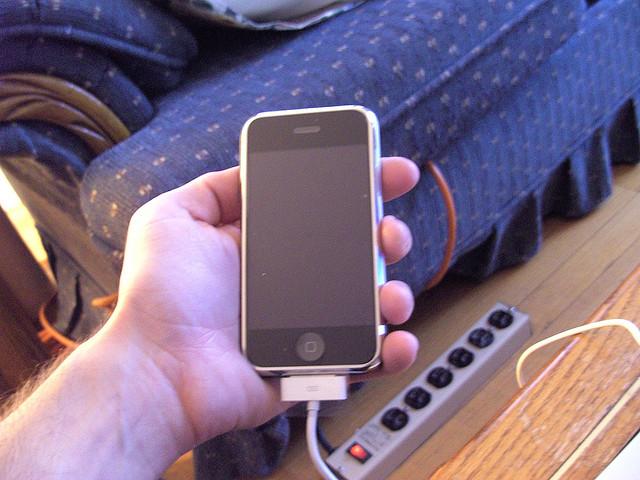What is the person holding?
Keep it brief. Phone. Is there a power strip?
Write a very short answer. Yes. Android or iPhone?
Give a very brief answer. Iphone. 